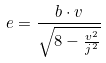<formula> <loc_0><loc_0><loc_500><loc_500>e = \frac { b \cdot v } { \sqrt { 8 - \frac { v ^ { 2 } } { j ^ { 2 } } } }</formula> 